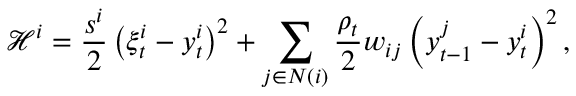Convert formula to latex. <formula><loc_0><loc_0><loc_500><loc_500>\mathcal { H } ^ { i } = \frac { s ^ { i } } { 2 } \left ( \xi _ { t } ^ { i } - y _ { t } ^ { i } \right ) ^ { 2 } + \sum _ { j \in N ( i ) } \frac { \rho _ { t } } { 2 } w _ { i j } \left ( y _ { t - 1 } ^ { j } - y _ { t } ^ { i } \right ) ^ { 2 } ,</formula> 